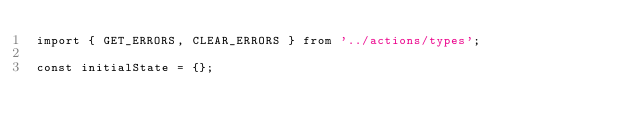Convert code to text. <code><loc_0><loc_0><loc_500><loc_500><_JavaScript_>import { GET_ERRORS, CLEAR_ERRORS } from '../actions/types';

const initialState = {};
</code> 